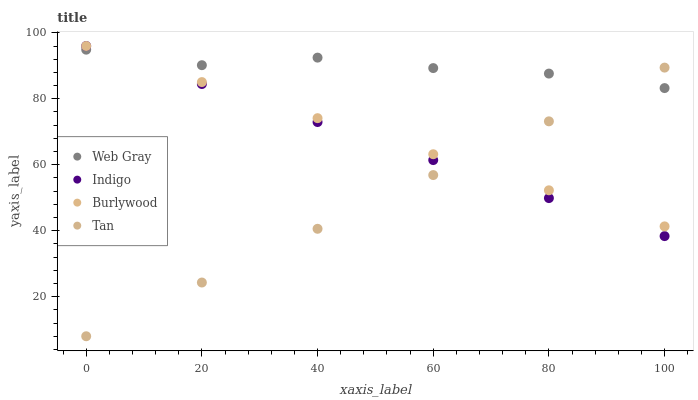Does Tan have the minimum area under the curve?
Answer yes or no. Yes. Does Web Gray have the maximum area under the curve?
Answer yes or no. Yes. Does Web Gray have the minimum area under the curve?
Answer yes or no. No. Does Tan have the maximum area under the curve?
Answer yes or no. No. Is Indigo the smoothest?
Answer yes or no. Yes. Is Web Gray the roughest?
Answer yes or no. Yes. Is Tan the smoothest?
Answer yes or no. No. Is Tan the roughest?
Answer yes or no. No. Does Tan have the lowest value?
Answer yes or no. Yes. Does Web Gray have the lowest value?
Answer yes or no. No. Does Indigo have the highest value?
Answer yes or no. Yes. Does Web Gray have the highest value?
Answer yes or no. No. Does Web Gray intersect Tan?
Answer yes or no. Yes. Is Web Gray less than Tan?
Answer yes or no. No. Is Web Gray greater than Tan?
Answer yes or no. No. 